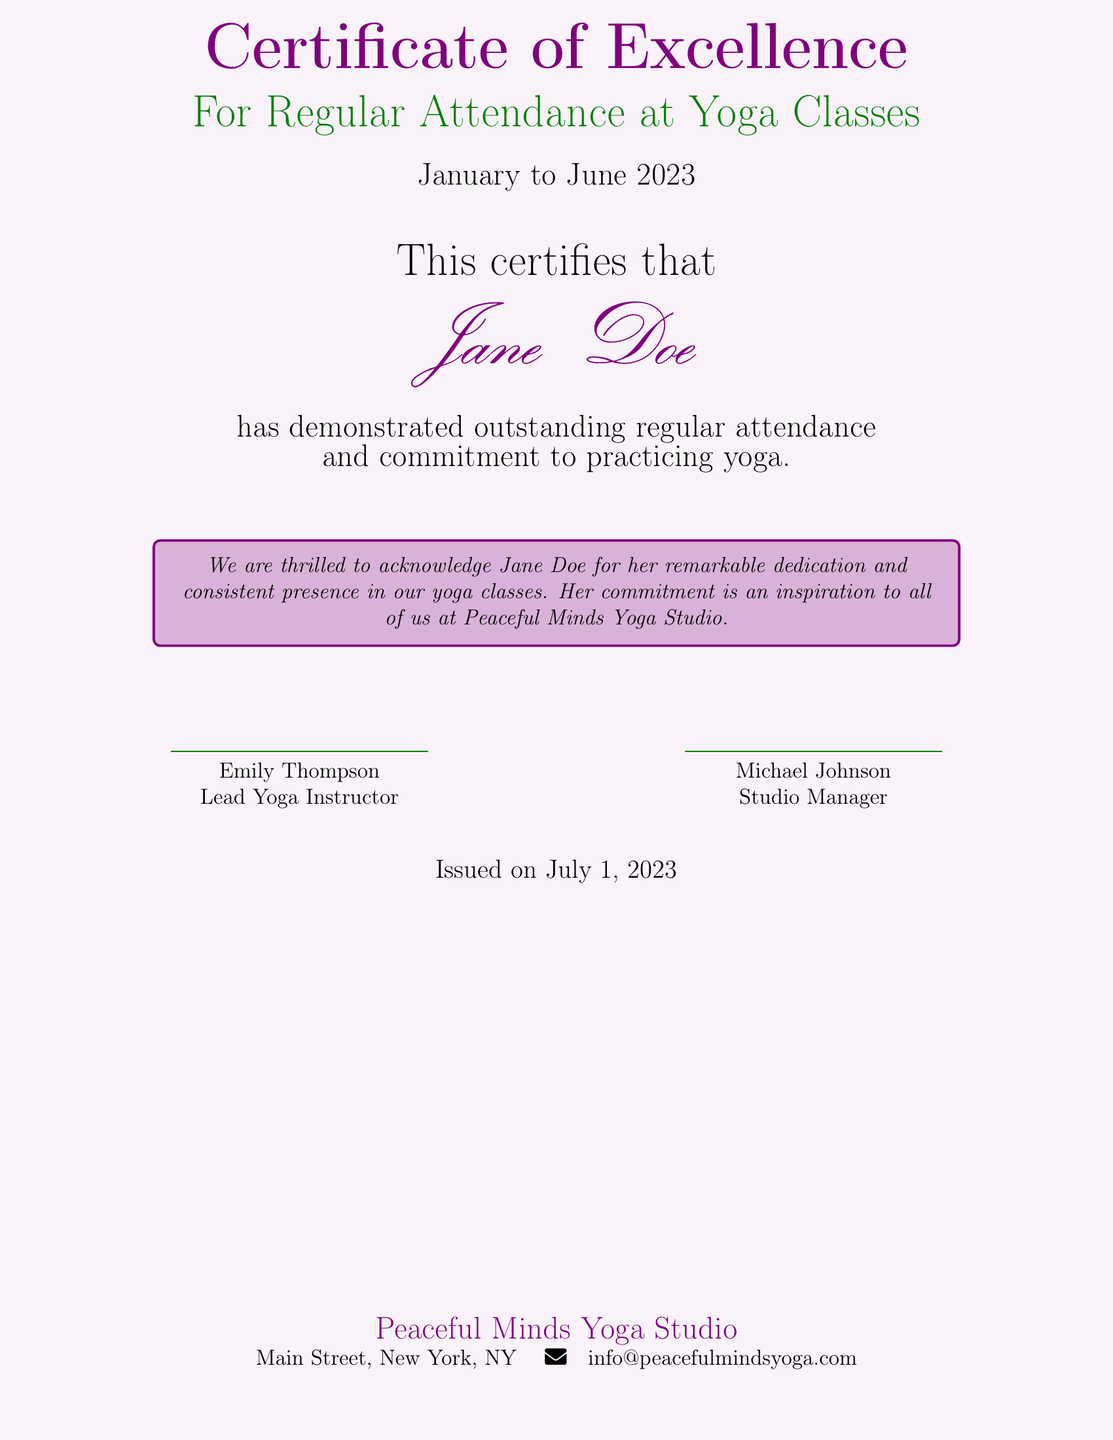What is the title of the certificate? The title is prominently displayed at the top of the document.
Answer: Certificate of Excellence Who is the recipient of this certificate? The recipient's name is shown in a distinctive font in the document.
Answer: Jane Doe What period does the certificate cover? The certificate mentions the specific duration of attendance.
Answer: January to June 2023 Who is the Lead Yoga Instructor? The Lead Yoga Instructor's name is located near the signature section.
Answer: Emily Thompson What is the studio's name? The studio's name is stated at the bottom of the document.
Answer: Peaceful Minds Yoga Studio What date was the certificate issued? The date of issuance is clearly indicated in the document.
Answer: July 1, 2023 What does the certificate acknowledge? The document specifies the individual's achievement.
Answer: Regular Attendance at Yoga Classes How is the recipient described in the acknowledgment box? The text in the acknowledgment box provides specific praise for the recipient.
Answer: Remarkable dedication and consistent presence Who is the Studio Manager? The Studio Manager's name is found next to a signature on the certificate.
Answer: Michael Johnson 